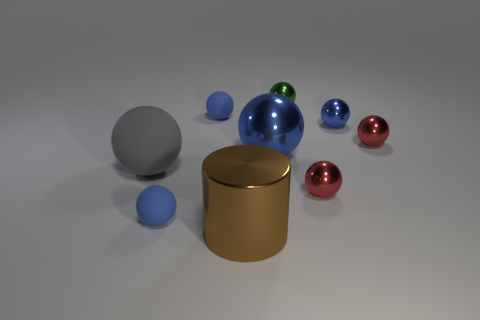Subtract all small blue balls. How many balls are left? 5 Subtract all red balls. How many yellow cylinders are left? 0 Add 3 gray rubber spheres. How many gray rubber spheres are left? 4 Add 7 big shiny cubes. How many big shiny cubes exist? 7 Subtract all blue balls. How many balls are left? 4 Subtract 1 brown cylinders. How many objects are left? 8 Subtract all spheres. How many objects are left? 1 Subtract 1 cylinders. How many cylinders are left? 0 Subtract all yellow cylinders. Subtract all red balls. How many cylinders are left? 1 Subtract all large rubber things. Subtract all small spheres. How many objects are left? 2 